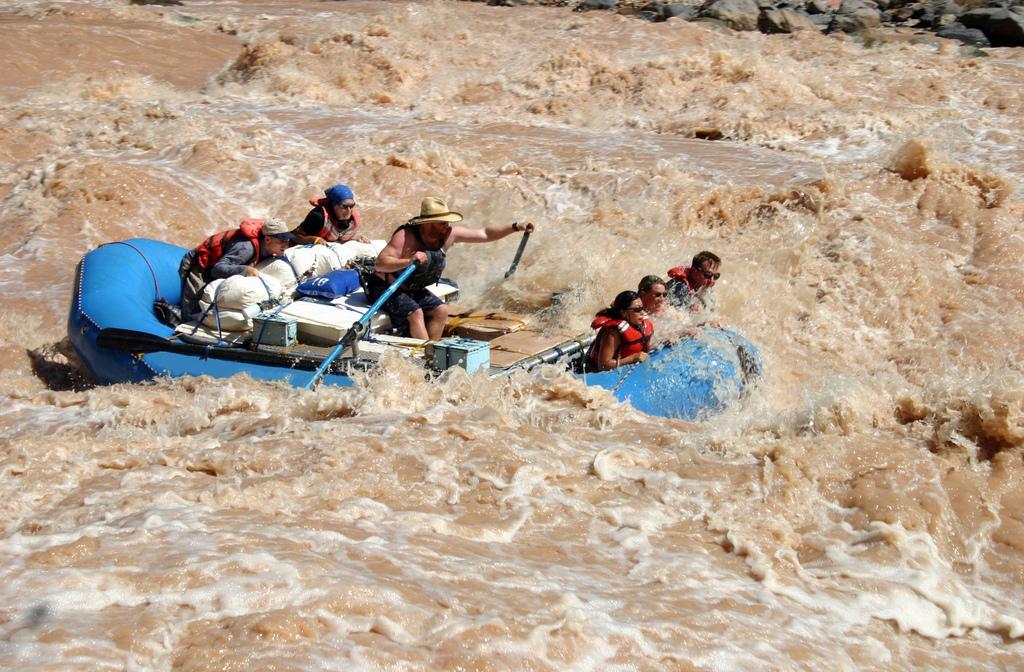Please provide a concise description of this image. In this picture there is a boat in the water. We can see three persons sitting in the front, and one in the middle, and two in the back. Here this person is riding the boat and he wear a cap. 